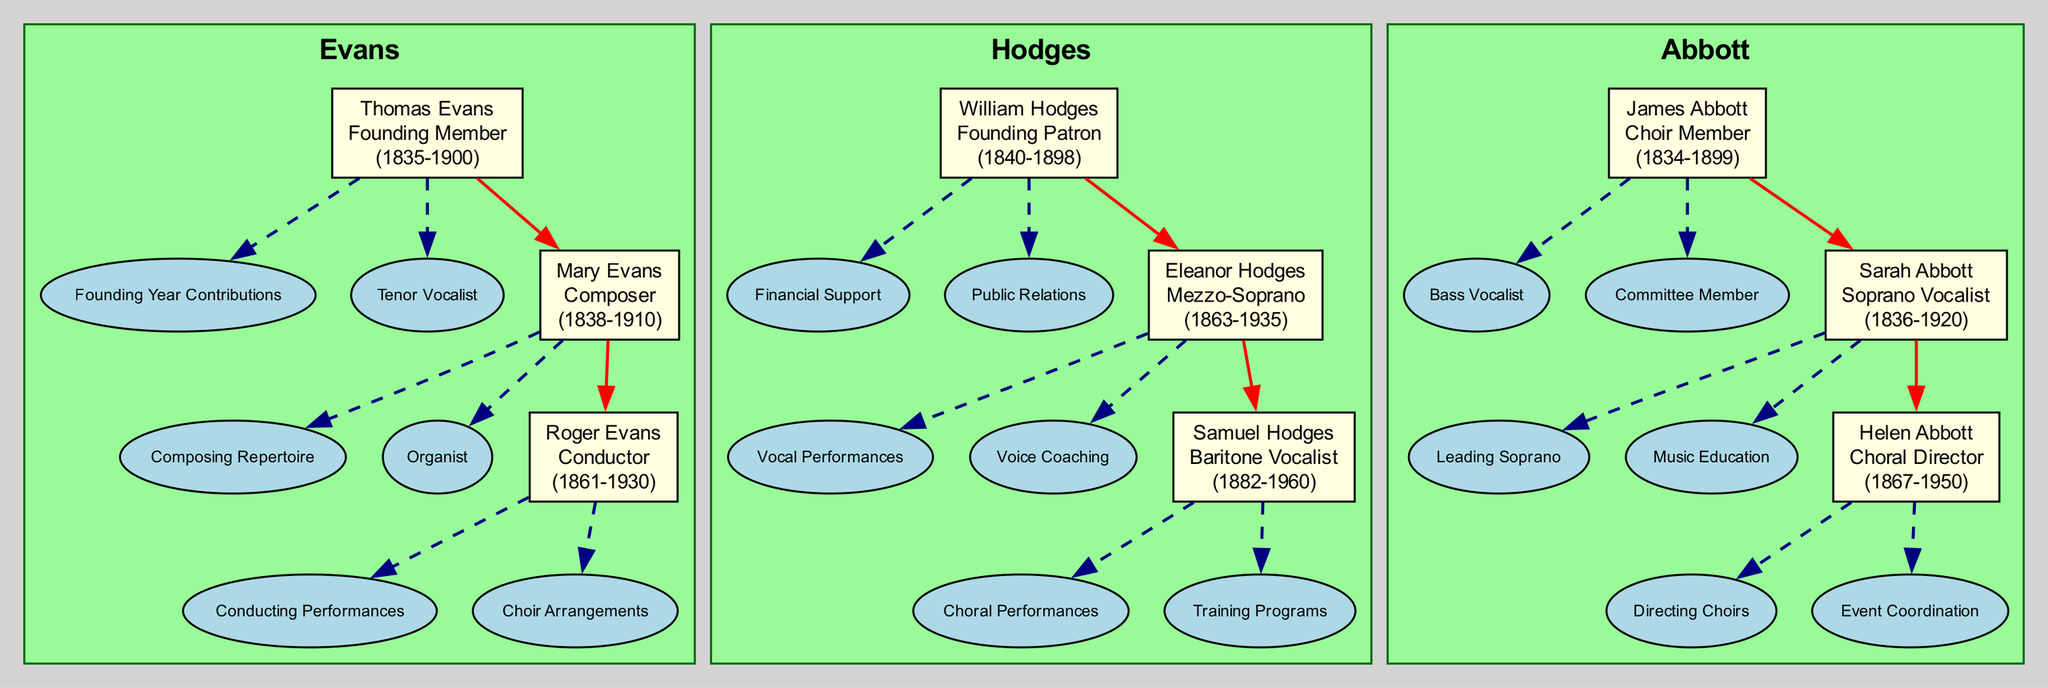What is the total number of family members depicted in the diagram? The diagram contains three families: Evans, Hodges, and Abbott. Each family has three members, totaling 9 family members (3 members per family x 3 families).
Answer: 9 Which member from the Evans family was a tenor vocalist? Within the Evans family, Thomas Evans is specifically noted as a tenor vocalist in his contributions section.
Answer: Thomas Evans Who was the founding patron of the Hodges family? According to the diagram, William Hodges holds the title of founding patron among the members of the Hodges family.
Answer: William Hodges What role did Helen Abbott play in the choir society? Helen Abbott is identified as a choral director in her role within the Abbott family.
Answer: Choral Director Which family member from the Abbott family lived the longest? Based on the years provided, Sarah Abbott lived from 1836 to 1920, making her lifespan the longest among Abbott family members who lived 84 years.
Answer: Sarah Abbott How many contributions did Roger Evans make? Roger Evans has made two specific contributions according to what is listed beneath his name in the diagram.
Answer: 2 Which vocalist in the Hodges family was born in 1882? Samuel Hodges is the vocalist from the Hodges family who was born in 1882 as mentioned in his birth year.
Answer: Samuel Hodges Who among the members of the Evans family was involved in composing repertoire? Mary Evans is the member of the Evans family who is noted for composing repertoire in her contributions.
Answer: Mary Evans What is the connection between the members of the Abbott family? The connections are represented as a sequential relationship where each member connects to the next, illustrating generational lines or roles played within the family context.
Answer: Sequential Relationship 